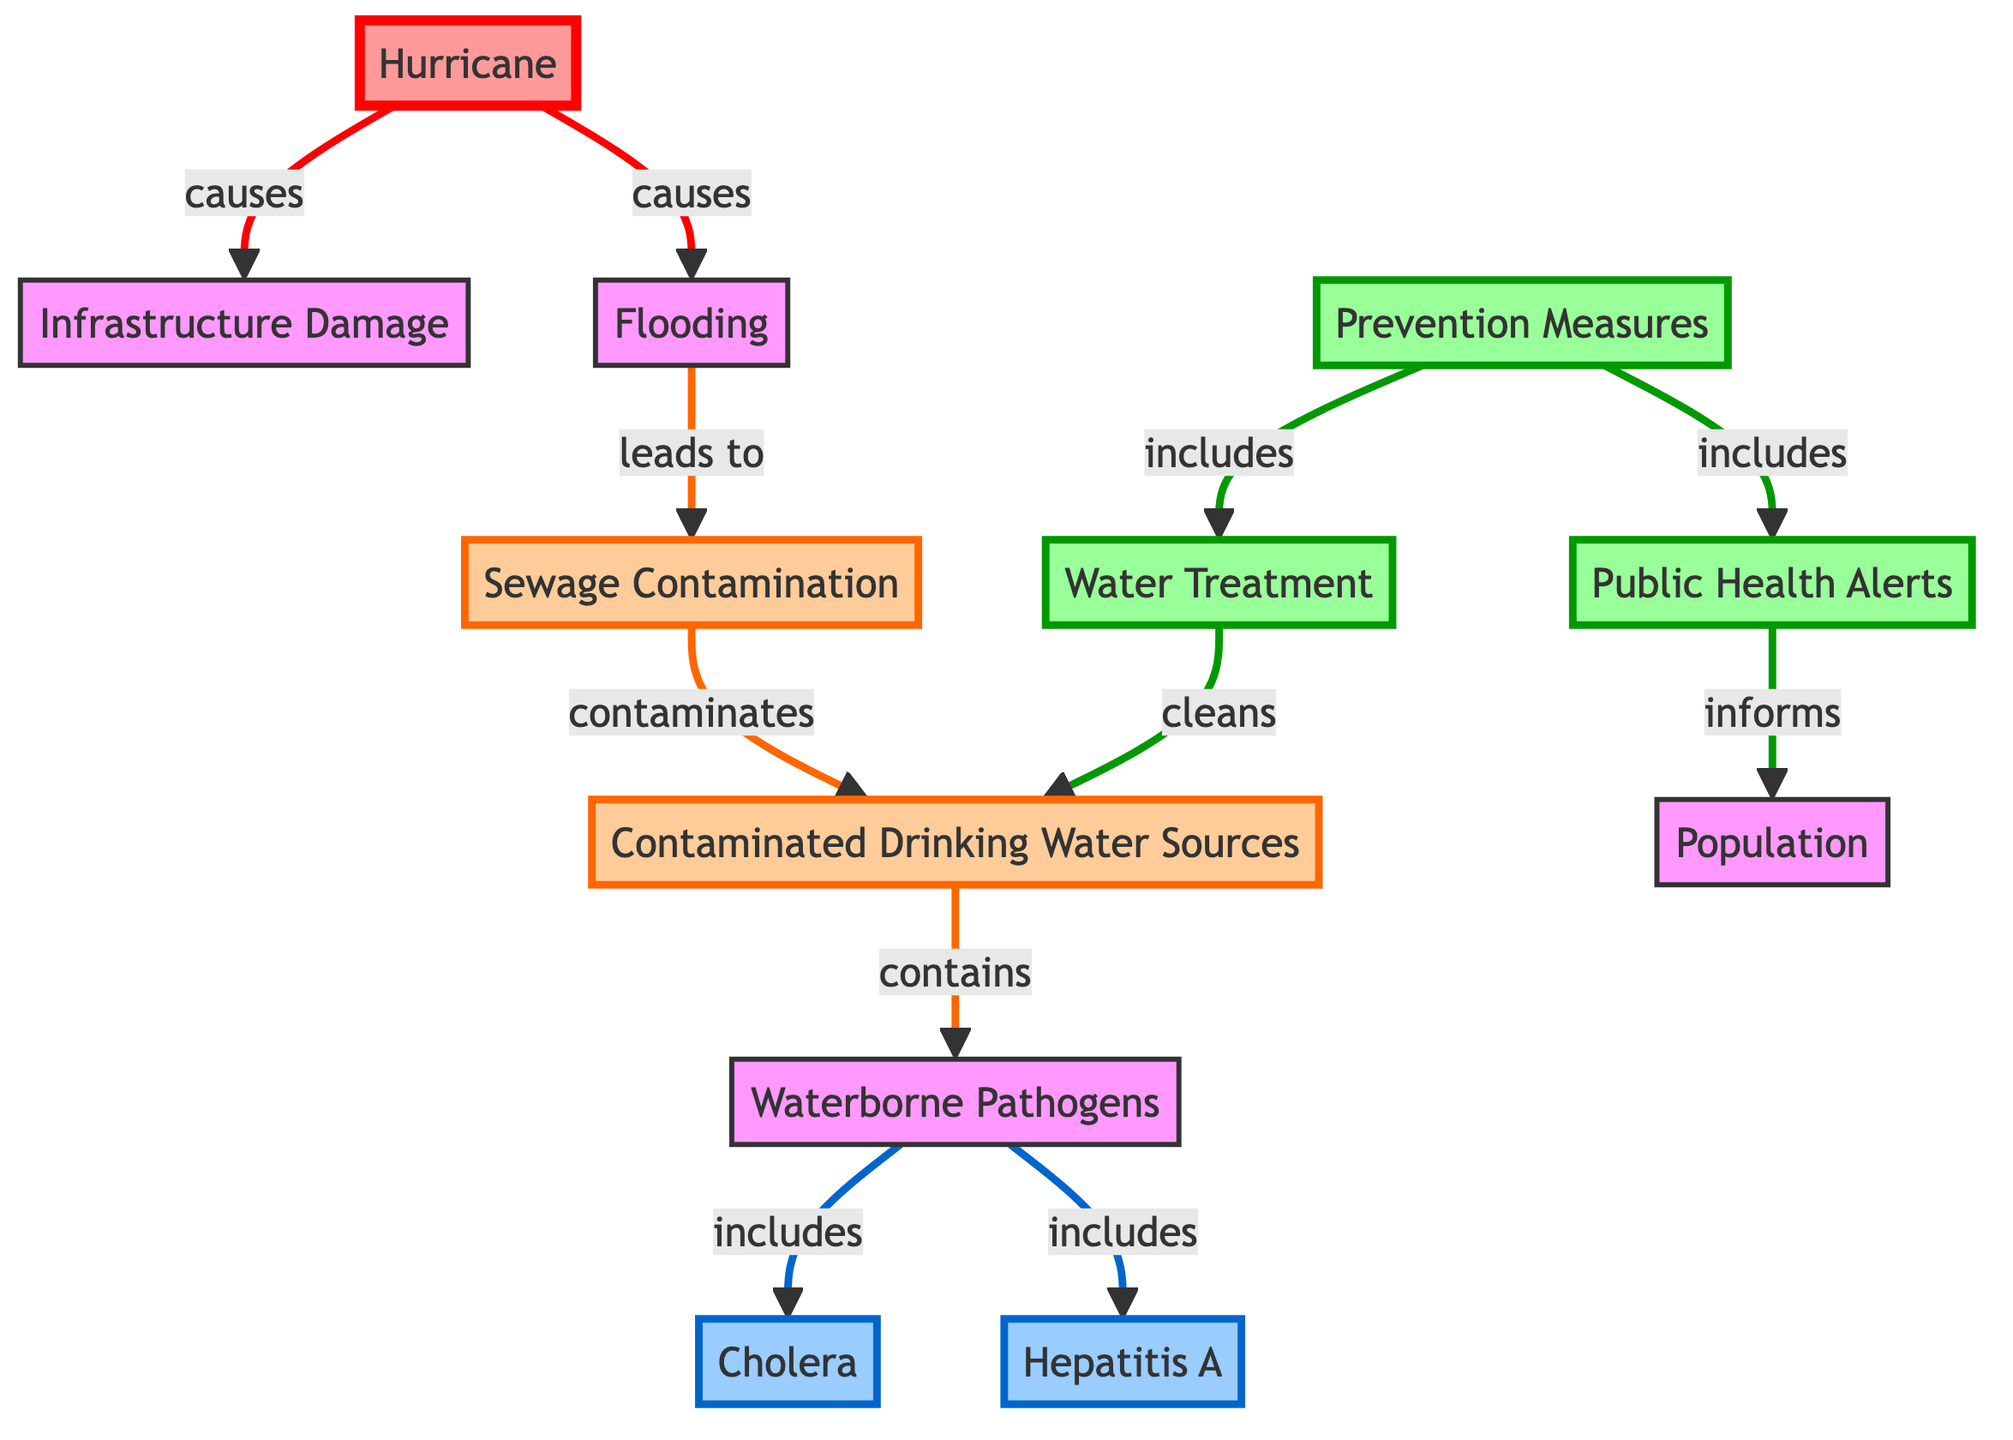What causes Sewage Contamination? The diagram indicates that Sewage Contamination is caused by Flooding, as shown by the directed arrow connecting Flooding to Sewage Contamination.
Answer: Flooding How many diseases are represented in the diagram? The diagram lists two diseases: Cholera and Hepatitis A, which are both included under the Waterborne Pathogens node. Therefore, the total count is two.
Answer: 2 What do Public Health Alerts inform? The diagram shows that Public Health Alerts inform the Population, as indicated by the arrow leading from Public Health Alerts to Population.
Answer: Population Which preventive measure cleans Drinking Water Sources? According to the diagram, Water Treatment is the preventive measure that cleans Drinking Water Sources, as shown by the directed arrow leading from Water Treatment to Drinking Water Sources.
Answer: Water Treatment What leads to Drinking Water Sources containing Pathogens? The flow in the diagram shows that Drinking Water Sources contain Pathogens as a result of being contaminated by Sewage Contamination, creating a direct link in the flow.
Answer: Sewage Contamination Name one pathogen included in Waterborne Pathogens. The diagram specifies that Cholera and Hepatitis A are both examples of pathogens included in Waterborne Pathogens. Therefore, one example would be Cholera.
Answer: Cholera Which two major events does a Hurricane cause? The diagram indicates that a Hurricane causes both Infrastructure Damage and Flooding, as shown by the two arrows stemming from the Hurricane node to these two effects.
Answer: Infrastructure Damage, Flooding What is the role of Water Treatment in this diagram? Water Treatment is illustrated in the diagram as a preventive measure that works to clean Drinking Water Sources, as indicated by the arrow from Water Treatment to Drinking Water Sources.
Answer: Cleans Drinking Water Sources 